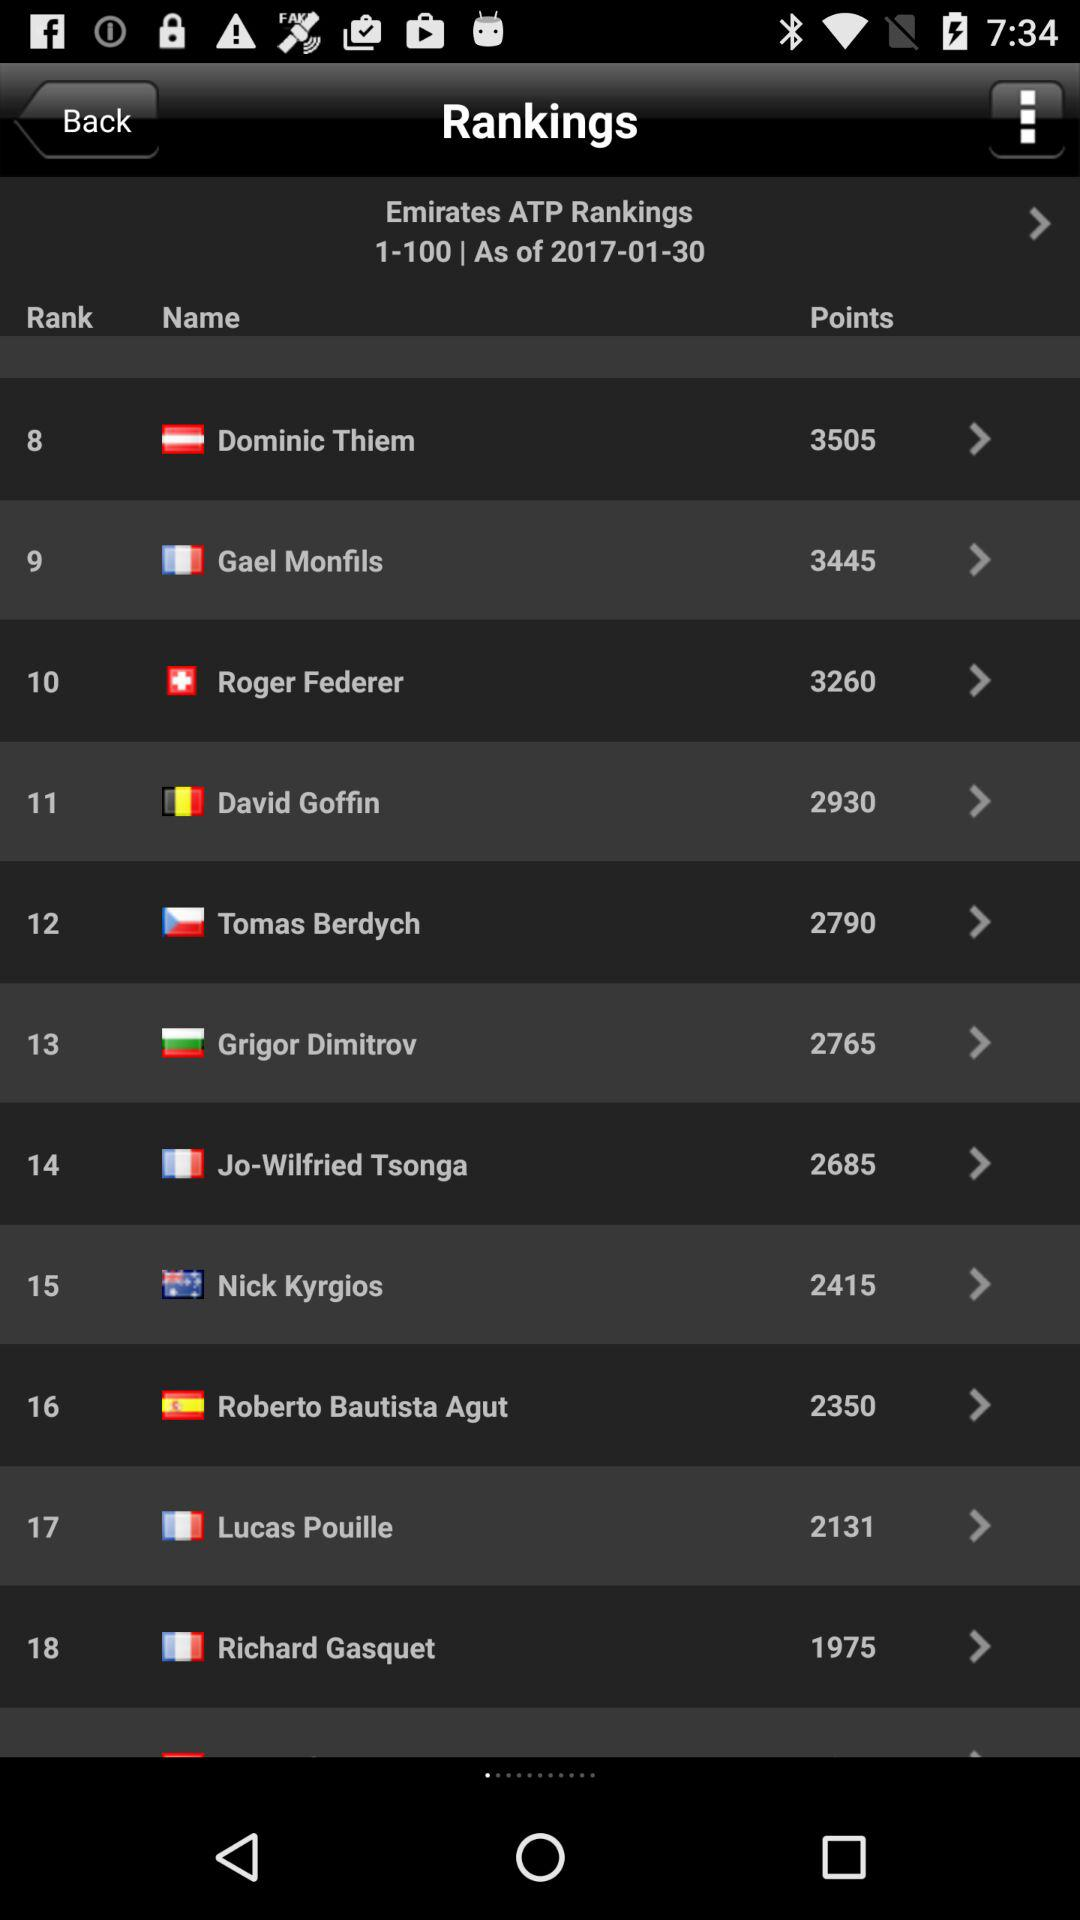What is the rank of Roger Federer? The rank of Roger Federer is 10. 